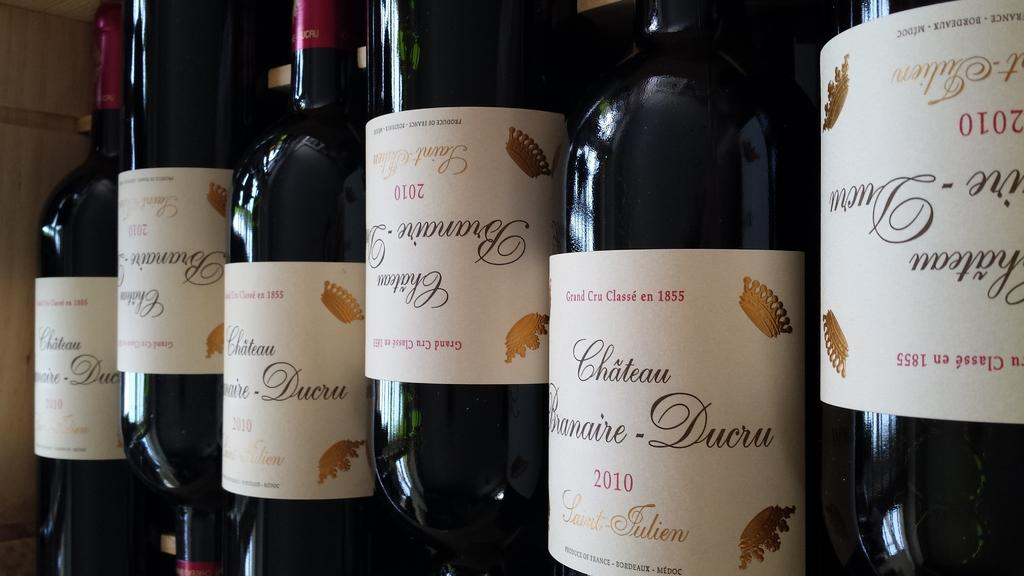<image>
Relay a brief, clear account of the picture shown. Several bottles of wine from 2010 are lined up together, some upside-down. 